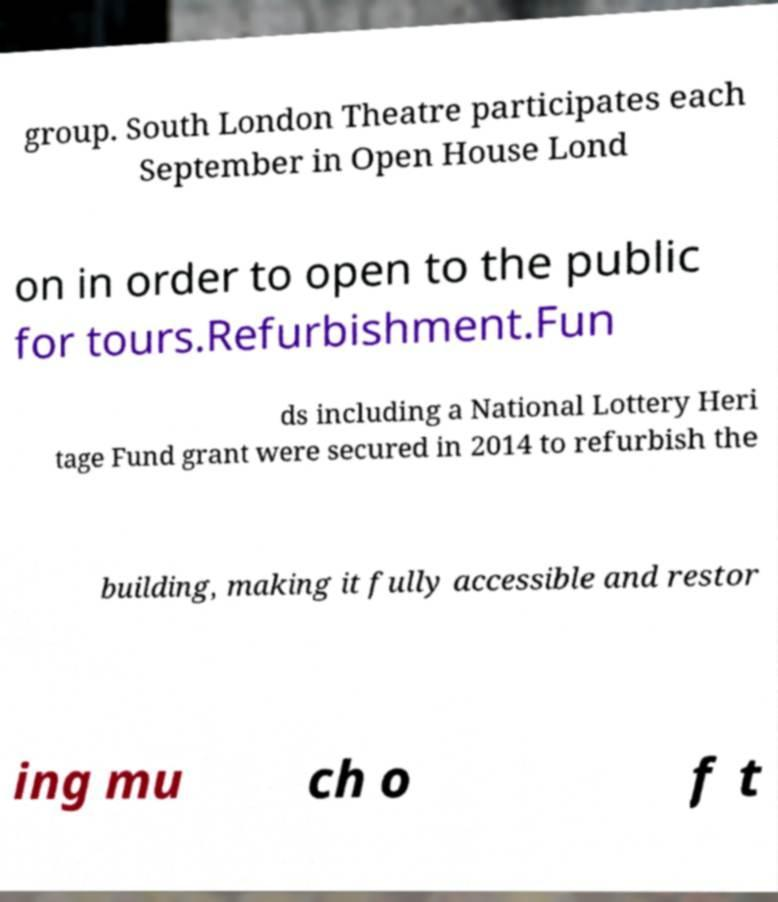Can you accurately transcribe the text from the provided image for me? group. South London Theatre participates each September in Open House Lond on in order to open to the public for tours.Refurbishment.Fun ds including a National Lottery Heri tage Fund grant were secured in 2014 to refurbish the building, making it fully accessible and restor ing mu ch o f t 